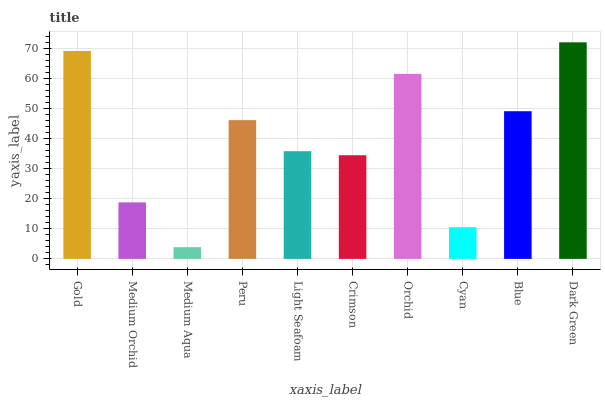Is Medium Orchid the minimum?
Answer yes or no. No. Is Medium Orchid the maximum?
Answer yes or no. No. Is Gold greater than Medium Orchid?
Answer yes or no. Yes. Is Medium Orchid less than Gold?
Answer yes or no. Yes. Is Medium Orchid greater than Gold?
Answer yes or no. No. Is Gold less than Medium Orchid?
Answer yes or no. No. Is Peru the high median?
Answer yes or no. Yes. Is Light Seafoam the low median?
Answer yes or no. Yes. Is Blue the high median?
Answer yes or no. No. Is Orchid the low median?
Answer yes or no. No. 